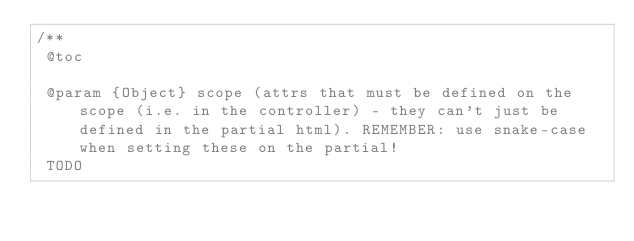Convert code to text. <code><loc_0><loc_0><loc_500><loc_500><_JavaScript_>/**
 @toc

 @param {Object} scope (attrs that must be defined on the scope (i.e. in the controller) - they can't just be defined in the partial html). REMEMBER: use snake-case when setting these on the partial!
 TODO
</code> 